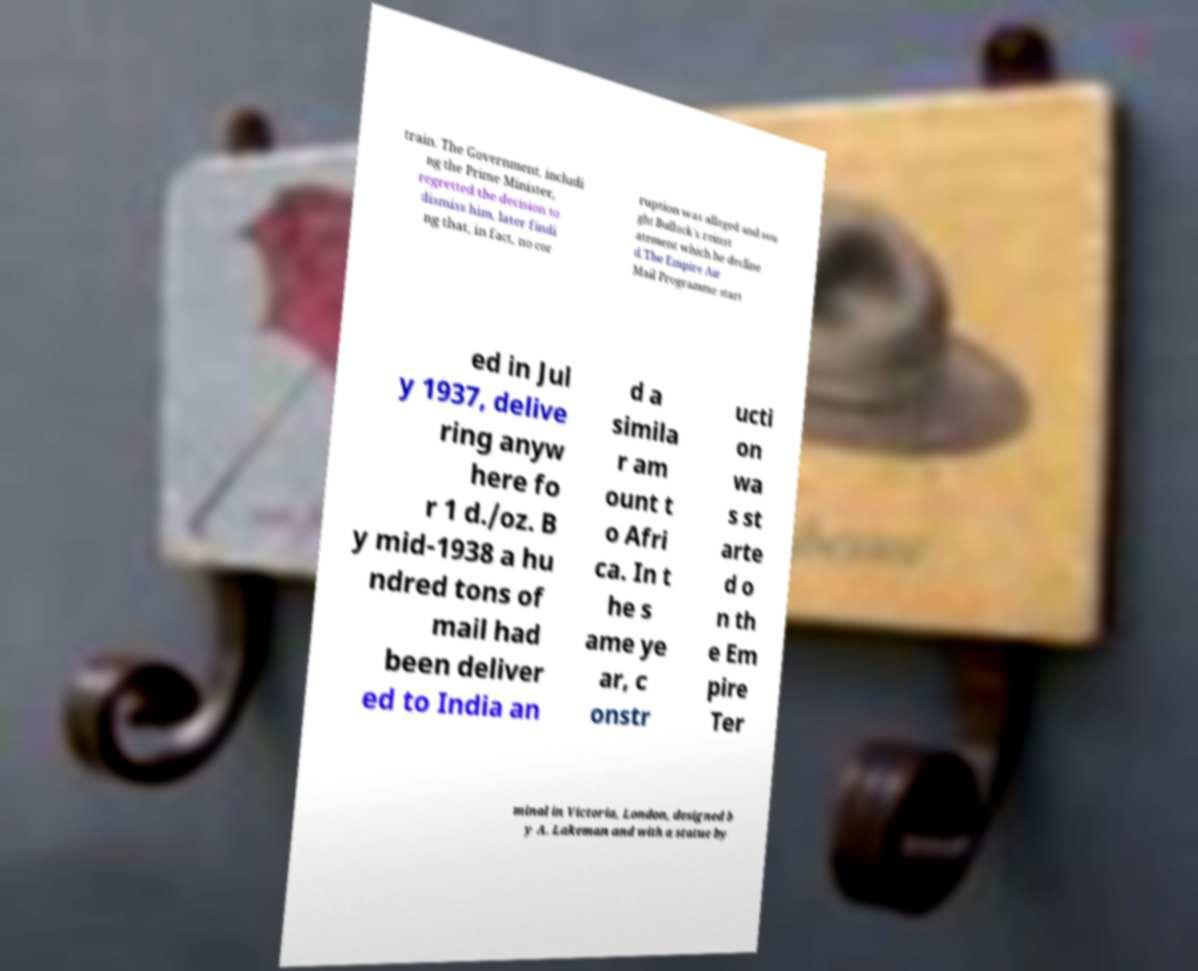Can you accurately transcribe the text from the provided image for me? train. The Government, includi ng the Prime Minister, regretted the decision to dismiss him, later findi ng that, in fact, no cor ruption was alleged and sou ght Bullock's reinst atement which he decline d.The Empire Air Mail Programme start ed in Jul y 1937, delive ring anyw here fo r 1 d./oz. B y mid-1938 a hu ndred tons of mail had been deliver ed to India an d a simila r am ount t o Afri ca. In t he s ame ye ar, c onstr ucti on wa s st arte d o n th e Em pire Ter minal in Victoria, London, designed b y A. Lakeman and with a statue by 